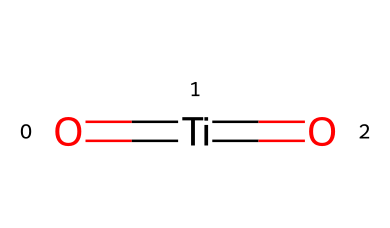How many oxygen atoms are present in the chemical structure? The chemical has two oxygen atoms visible in its structure, as indicated by the two 'O' symbols in the SMILES representation.
Answer: two What is the central atom in this chemical structure? The central atom is titanium, which is represented by the 'Ti' in the SMILES. This atom serves as the core of the molecule, bonded to the oxygen atoms.
Answer: titanium How many double bonds are present in the structure? The chemical has two double bonds, indicated by the '=' signs connecting the titanium to the oxygen atoms.
Answer: two What type of pigment is this chemical likely to be associated with? This chemical structure suggests that it is related to durable white pigments, often used for applications such as basketball court lines.
Answer: white pigment Does this chemical have stable isotopes? Yes, titanium has stable isotopes, such as Titanium-46, Titanium-47, and Titanium-48, which make it useful in various applications, including pigments.
Answer: yes 